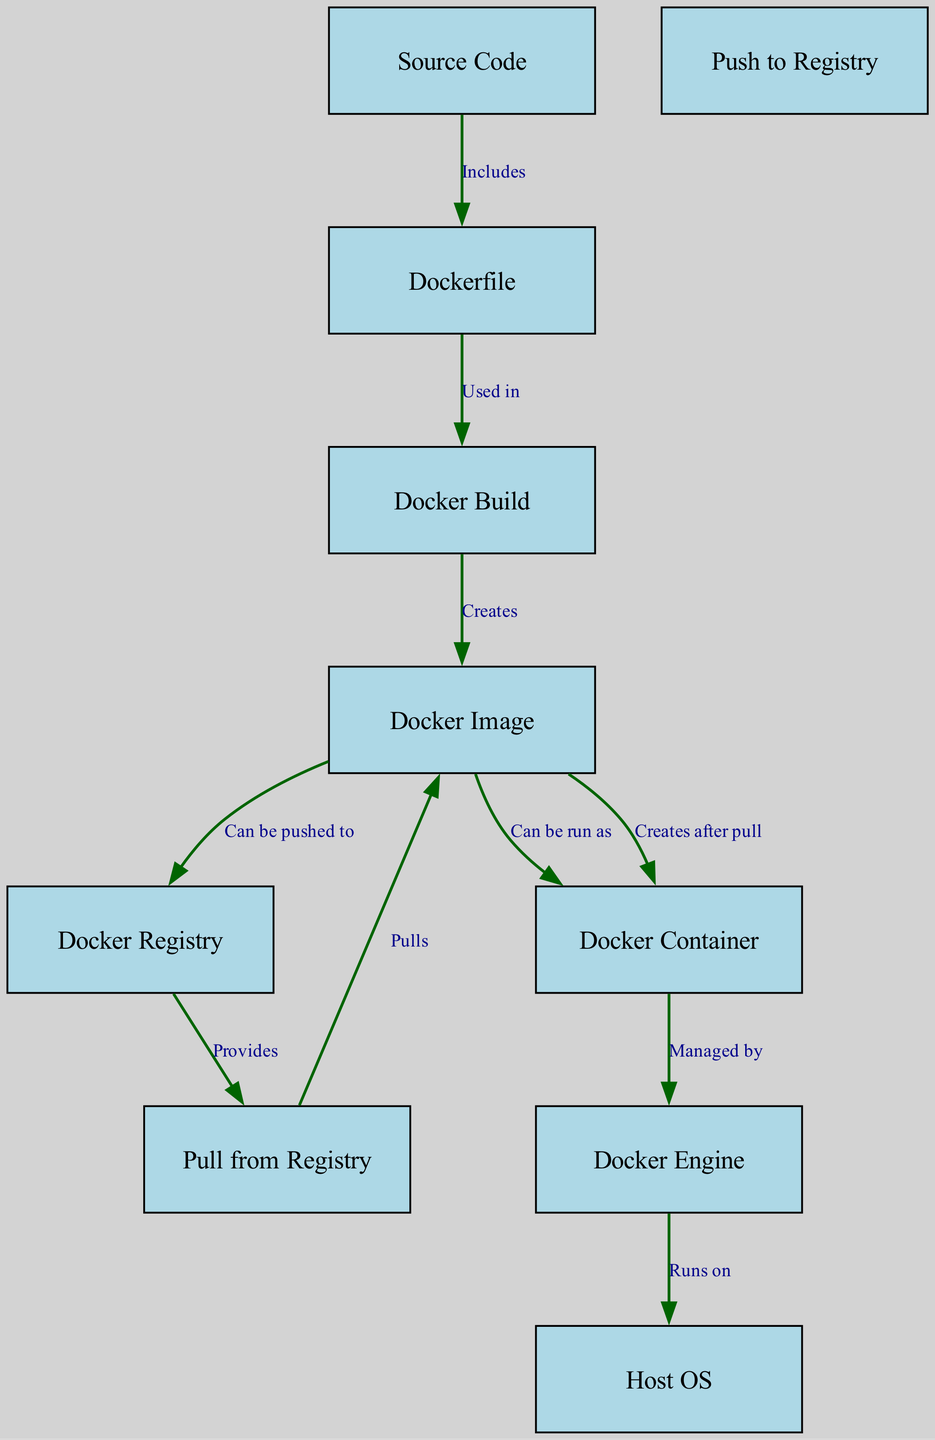What's the number of nodes in the diagram? To find the number of nodes, we can count the entries in the "nodes" section of the data. There are 10 distinct nodes listed.
Answer: 10 Which node is the source of the Dockerfile? The source node for the Dockerfile is the Source Code node, as the diagram indicates a relationship labeled "Includes" from the Source Code to Dockerfile.
Answer: Source Code What command is used to create a Docker image? In the diagram, the command that creates a Docker image is the Docker Build command, which is connected by an edge labeled "Creates" to the Docker Image node.
Answer: Docker Build What can a Docker image be run as? According to the diagram, a Docker image can be run as a Docker Container, illustrated by the edge labeled "Can be run as" from the Docker Image to the Docker Container.
Answer: Docker Container What command pulls an image from the Docker registry? The command that pulls an image from the Docker registry is the Pull from Registry command, which is indicated by the edge pointing towards the Docker Image node labeled "Pulls."
Answer: Pull from Registry Describe the relationship between Docker Image and Docker Registry. The relationship is that a Docker Image can be pushed to the Docker Registry, as shown by the edge labeled "Can be pushed to" connecting these two nodes.
Answer: Can be pushed to Explain how a Docker Container is created after a pull. When an image is pulled from the Docker registry, it is stored locally first. The Docker Container then gets created from this image, as indicated by the sequence of edges: Pull from Registry to Docker Image and then Docker Image to Docker Container (labeled "Creates after pull").
Answer: Creates after pull Which component manages the Docker Container? The component that manages the Docker Container is the Docker Engine, as shown by the directed edge labeled "Managed by" leading from Docker Container to Docker Engine.
Answer: Docker Engine What runs on the Host OS? The Docker Engine runs on the Host OS, which is indicated by the edge labeled "Runs on" from Docker Engine to Host OS in the diagram.
Answer: Docker Engine 